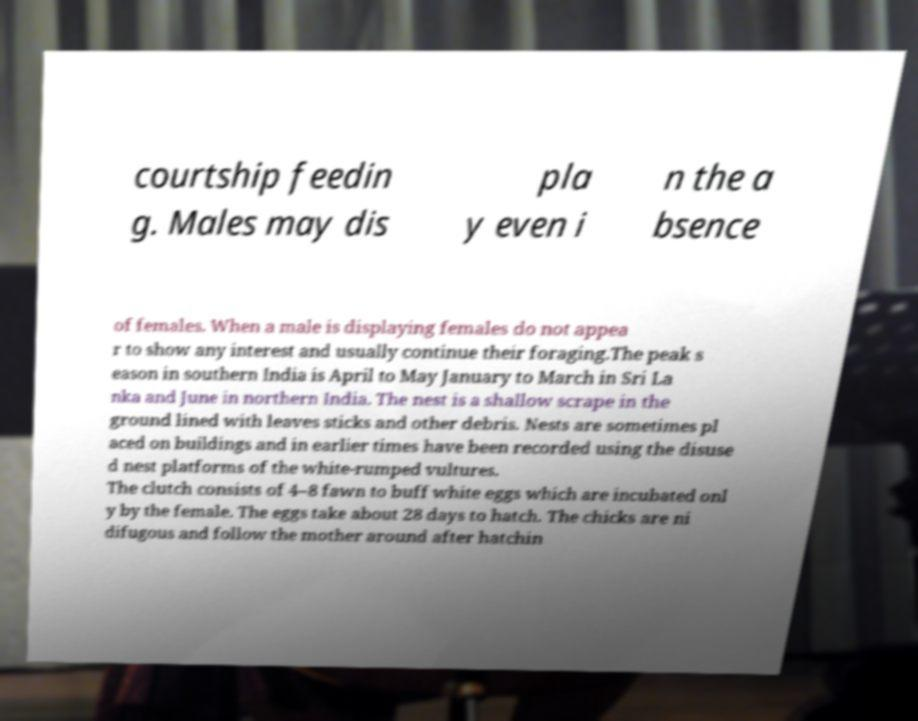I need the written content from this picture converted into text. Can you do that? courtship feedin g. Males may dis pla y even i n the a bsence of females. When a male is displaying females do not appea r to show any interest and usually continue their foraging.The peak s eason in southern India is April to May January to March in Sri La nka and June in northern India. The nest is a shallow scrape in the ground lined with leaves sticks and other debris. Nests are sometimes pl aced on buildings and in earlier times have been recorded using the disuse d nest platforms of the white-rumped vultures. The clutch consists of 4–8 fawn to buff white eggs which are incubated onl y by the female. The eggs take about 28 days to hatch. The chicks are ni difugous and follow the mother around after hatchin 